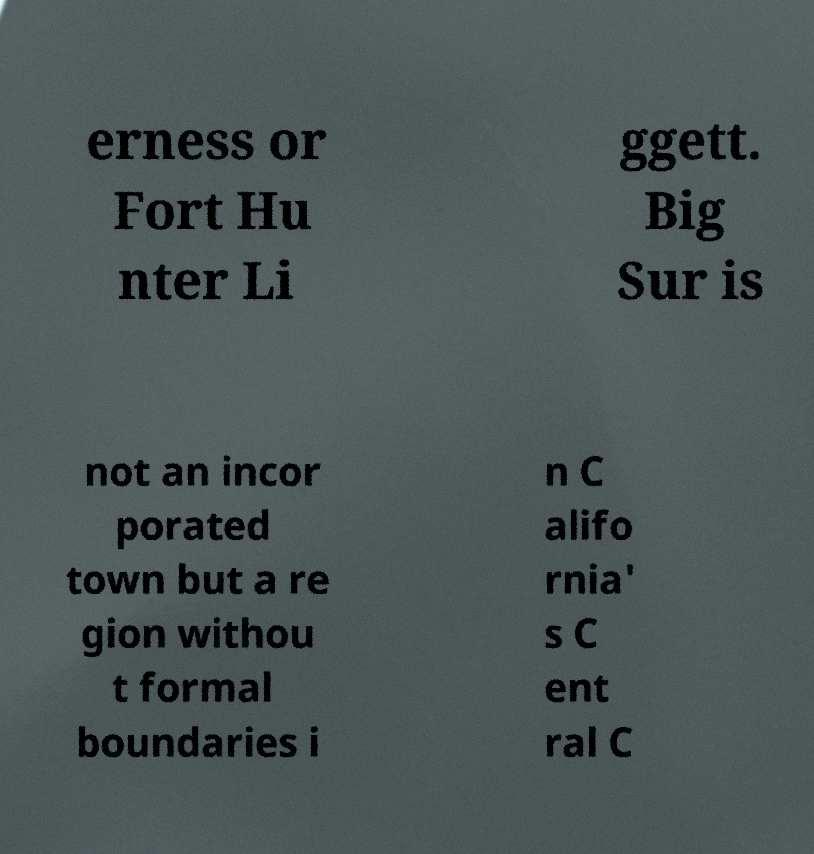Could you assist in decoding the text presented in this image and type it out clearly? erness or Fort Hu nter Li ggett. Big Sur is not an incor porated town but a re gion withou t formal boundaries i n C alifo rnia' s C ent ral C 